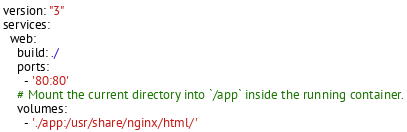Convert code to text. <code><loc_0><loc_0><loc_500><loc_500><_YAML_>version: "3"
services:
  web:
    build: ./
    ports:
      - '80:80'
    # Mount the current directory into `/app` inside the running container.
    volumes:
      - './app:/usr/share/nginx/html/'</code> 